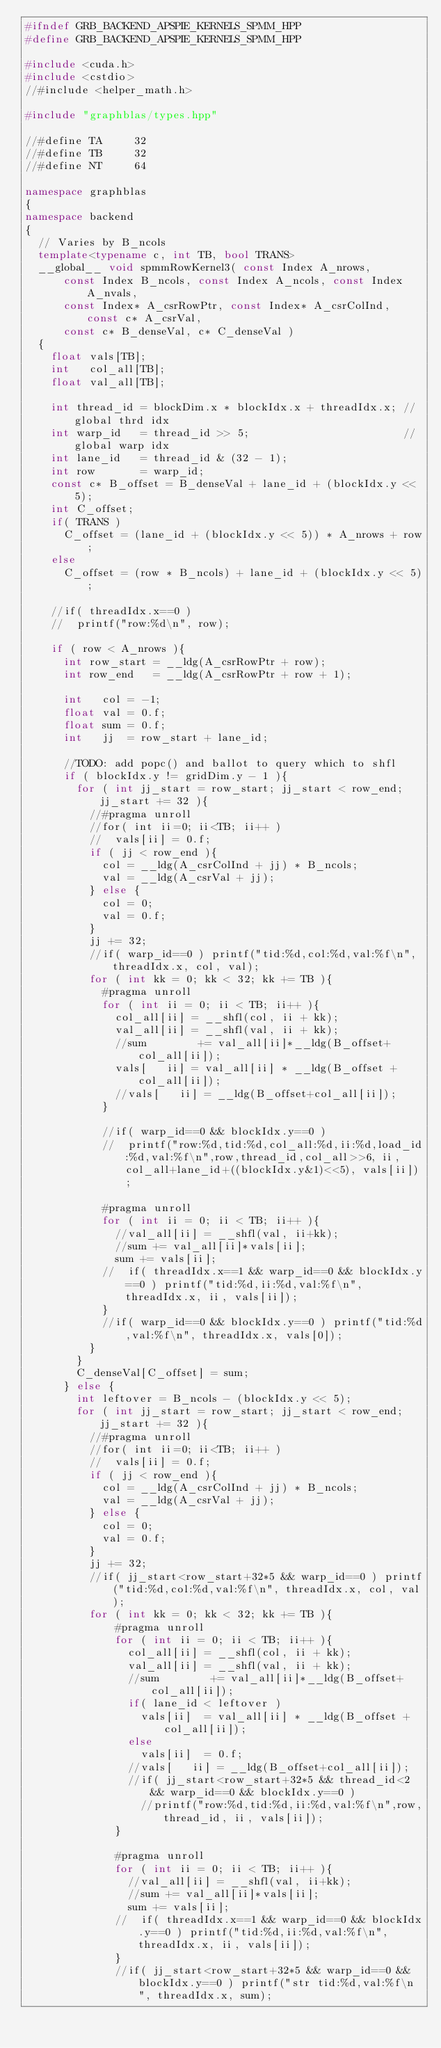Convert code to text. <code><loc_0><loc_0><loc_500><loc_500><_C++_>#ifndef GRB_BACKEND_APSPIE_KERNELS_SPMM_HPP
#define GRB_BACKEND_APSPIE_KERNELS_SPMM_HPP

#include <cuda.h>
#include <cstdio>
//#include <helper_math.h>

#include "graphblas/types.hpp"

//#define TA     32
//#define TB     32
//#define NT     64

namespace graphblas
{
namespace backend
{
  // Varies by B_ncols
  template<typename c, int TB, bool TRANS>
  __global__ void spmmRowKernel3( const Index A_nrows, 
      const Index B_ncols, const Index A_ncols, const Index A_nvals,
      const Index* A_csrRowPtr, const Index* A_csrColInd, const c* A_csrVal, 
      const c* B_denseVal, c* C_denseVal )
  {
    float vals[TB];
    int   col_all[TB];
    float val_all[TB];

    int thread_id = blockDim.x * blockIdx.x + threadIdx.x; // global thrd idx
    int warp_id   = thread_id >> 5;                        // global warp idx
    int lane_id   = thread_id & (32 - 1);
    int row       = warp_id;
    const c* B_offset = B_denseVal + lane_id + (blockIdx.y << 5);
    int C_offset;
	  if( TRANS )
		  C_offset = (lane_id + (blockIdx.y << 5)) * A_nrows + row;
		else
		  C_offset = (row * B_ncols) + lane_id + (blockIdx.y << 5);

    //if( threadIdx.x==0 )
    //  printf("row:%d\n", row);

    if ( row < A_nrows ){
      int row_start = __ldg(A_csrRowPtr + row);
      int row_end   = __ldg(A_csrRowPtr + row + 1);

      int   col = -1;
      float val = 0.f;
      float sum = 0.f;
      int   jj  = row_start + lane_id;

      //TODO: add popc() and ballot to query which to shfl
      if ( blockIdx.y != gridDim.y - 1 ){
        for ( int jj_start = row_start; jj_start < row_end; jj_start += 32 ){
          //#pragma unroll
          //for( int ii=0; ii<TB; ii++ )
          //  vals[ii] = 0.f;
          if ( jj < row_end ){
            col = __ldg(A_csrColInd + jj) * B_ncols;
            val = __ldg(A_csrVal + jj);
          } else {
            col = 0;
            val = 0.f;
          }
          jj += 32;
          //if( warp_id==0 ) printf("tid:%d,col:%d,val:%f\n", threadIdx.x, col, val);
          for ( int kk = 0; kk < 32; kk += TB ){
            #pragma unroll
            for ( int ii = 0; ii < TB; ii++ ){
              col_all[ii] = __shfl(col, ii + kk);
              val_all[ii] = __shfl(val, ii + kk);
              //sum        += val_all[ii]*__ldg(B_offset+col_all[ii]);
              vals[   ii] = val_all[ii] * __ldg(B_offset + col_all[ii]);
              //vals[   ii] = __ldg(B_offset+col_all[ii]);
            }

            //if( warp_id==0 && blockIdx.y==0 )
            //  printf("row:%d,tid:%d,col_all:%d,ii:%d,load_id:%d,val:%f\n",row,thread_id,col_all>>6, ii, col_all+lane_id+((blockIdx.y&1)<<5), vals[ii]);

            #pragma unroll
            for ( int ii = 0; ii < TB; ii++ ){
              //val_all[ii] = __shfl(val, ii+kk);
              //sum += val_all[ii]*vals[ii];
              sum += vals[ii];
            //  if( threadIdx.x==1 && warp_id==0 && blockIdx.y==0 ) printf("tid:%d,ii:%d,val:%f\n", threadIdx.x, ii, vals[ii]);
            }
            //if( warp_id==0 && blockIdx.y==0 ) printf("tid:%d,val:%f\n", threadIdx.x, vals[0]);
          }
        }
        C_denseVal[C_offset] = sum;
      } else {
        int leftover = B_ncols - (blockIdx.y << 5);
        for ( int jj_start = row_start; jj_start < row_end; jj_start += 32 ){
          //#pragma unroll
          //for( int ii=0; ii<TB; ii++ )
          //  vals[ii] = 0.f;
          if ( jj < row_end ){
            col = __ldg(A_csrColInd + jj) * B_ncols;
            val = __ldg(A_csrVal + jj);
          } else {
            col = 0;
            val = 0.f;
          }
          jj += 32;
          //if( jj_start<row_start+32*5 && warp_id==0 ) printf("tid:%d,col:%d,val:%f\n", threadIdx.x, col, val);
          for ( int kk = 0; kk < 32; kk += TB ){
              #pragma unroll
              for ( int ii = 0; ii < TB; ii++ ){
                col_all[ii] = __shfl(col, ii + kk);
                val_all[ii] = __shfl(val, ii + kk);
                //sum        += val_all[ii]*__ldg(B_offset+col_all[ii]);
                if( lane_id < leftover )
                  vals[ii]  = val_all[ii] * __ldg(B_offset + col_all[ii]);
                else
                  vals[ii]  = 0.f;
                //vals[   ii] = __ldg(B_offset+col_all[ii]);
                //if( jj_start<row_start+32*5 && thread_id<2 && warp_id==0 && blockIdx.y==0 )
                  //printf("row:%d,tid:%d,ii:%d,val:%f\n",row,thread_id, ii, vals[ii]);
              }

              #pragma unroll
              for ( int ii = 0; ii < TB; ii++ ){
                //val_all[ii] = __shfl(val, ii+kk);
                //sum += val_all[ii]*vals[ii];
                sum += vals[ii];
              //  if( threadIdx.x==1 && warp_id==0 && blockIdx.y==0 ) printf("tid:%d,ii:%d,val:%f\n", threadIdx.x, ii, vals[ii]);
              }
              //if( jj_start<row_start+32*5 && warp_id==0 && blockIdx.y==0 ) printf("str tid:%d,val:%f\n", threadIdx.x, sum);</code> 